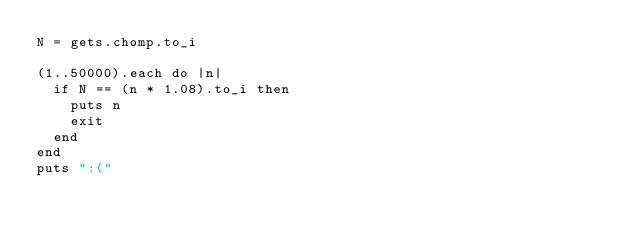Convert code to text. <code><loc_0><loc_0><loc_500><loc_500><_Ruby_>N = gets.chomp.to_i

(1..50000).each do |n|
  if N == (n * 1.08).to_i then
    puts n
    exit
  end
end
puts ":("</code> 